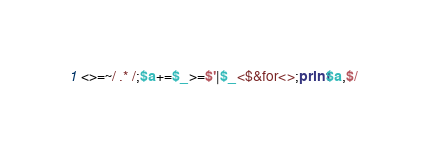<code> <loc_0><loc_0><loc_500><loc_500><_Perl_><>=~/ .* /;$a+=$_>=$'|$_<$&for<>;print$a,$/</code> 